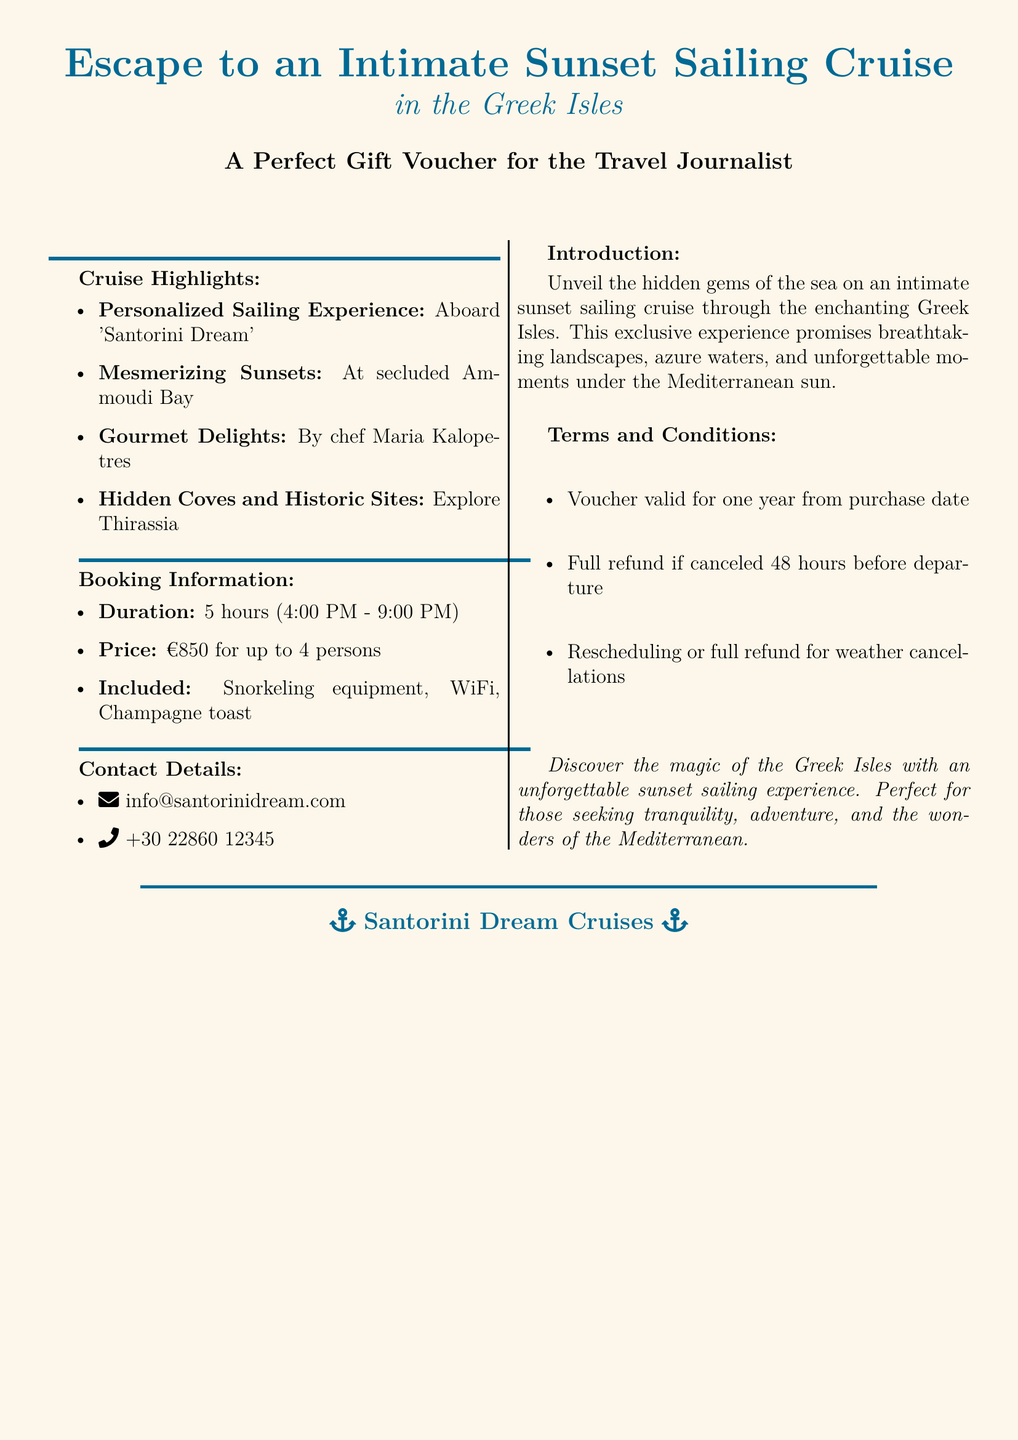What is the price for the cruise? The price for the cruise is stated as €850 for up to 4 persons.
Answer: €850 What is included in the cruise experience? The document lists snorkeling equipment, WiFi, and a Champagne toast as included in the cruise experience.
Answer: Snorkeling equipment, WiFi, Champagne toast What do you get to explore during the cruise? The document mentions exploring hidden coves and historic sites, specifically Thirassia.
Answer: Thirassia What time does the cruise start? According to the document, the cruise starts at 4:00 PM.
Answer: 4:00 PM What is the duration of the sailing cruise? The document specifies that the duration of the sailing cruise is 5 hours.
Answer: 5 hours How long is the voucher valid for? The validity of the voucher is mentioned as one year from the purchase date.
Answer: One year What will you enjoy at Ammoudi Bay during the cruise? The document highlights mesmerizing sunsets at secluded Ammoudi Bay.
Answer: Mesmerizing sunsets What is the contact email for Santorini Dream? The document provides the contact email as info@santorinidream.com.
Answer: info@santorinidream.com What type of sailing experience is offered? The document describes it as a personalized sailing experience aboard 'Santorini Dream'.
Answer: Personalized sailing experience 